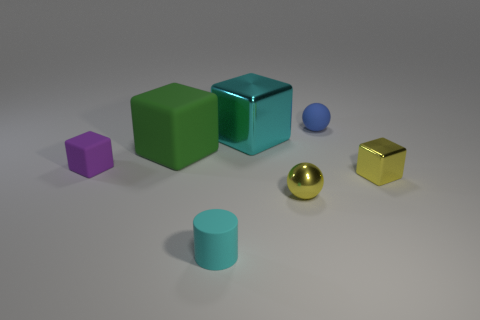Subtract 1 cubes. How many cubes are left? 3 Add 1 tiny cylinders. How many objects exist? 8 Subtract all cubes. How many objects are left? 3 Subtract all small gray shiny cubes. Subtract all small blue rubber spheres. How many objects are left? 6 Add 7 big cyan cubes. How many big cyan cubes are left? 8 Add 6 small blue matte objects. How many small blue matte objects exist? 7 Subtract 0 cyan balls. How many objects are left? 7 